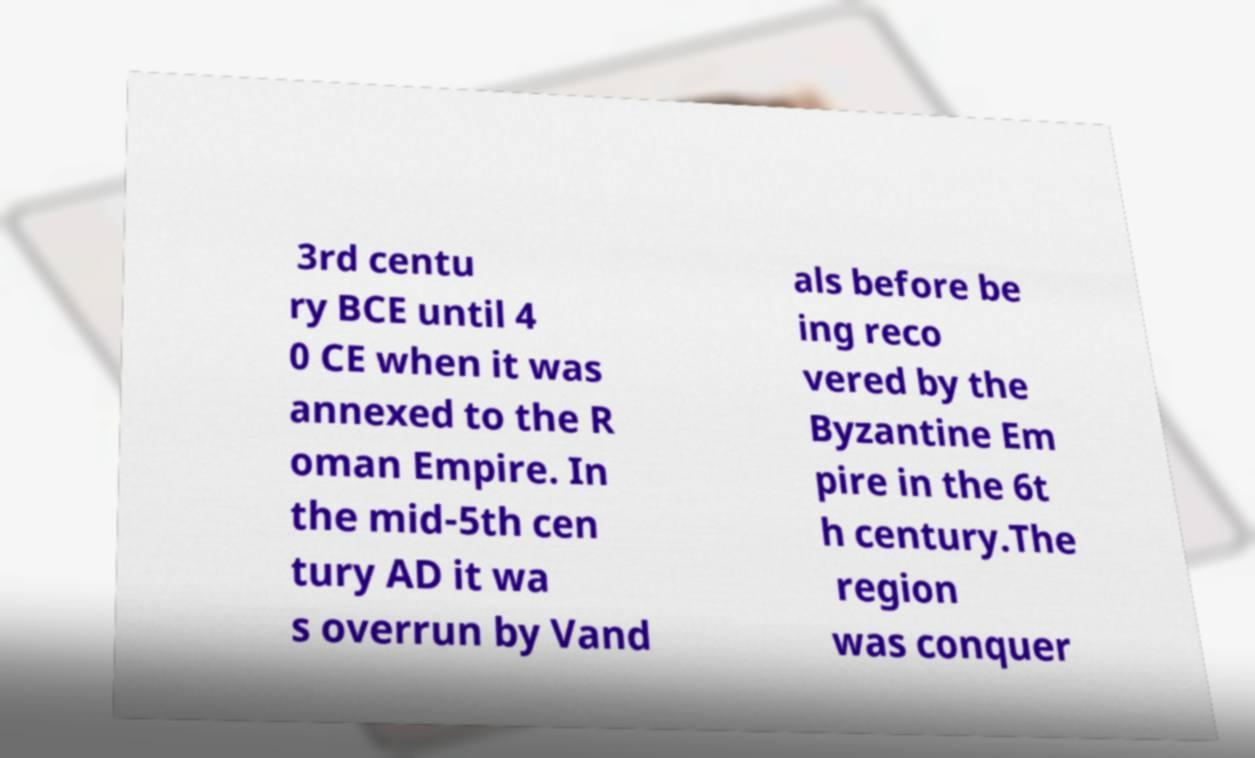Could you assist in decoding the text presented in this image and type it out clearly? 3rd centu ry BCE until 4 0 CE when it was annexed to the R oman Empire. In the mid-5th cen tury AD it wa s overrun by Vand als before be ing reco vered by the Byzantine Em pire in the 6t h century.The region was conquer 